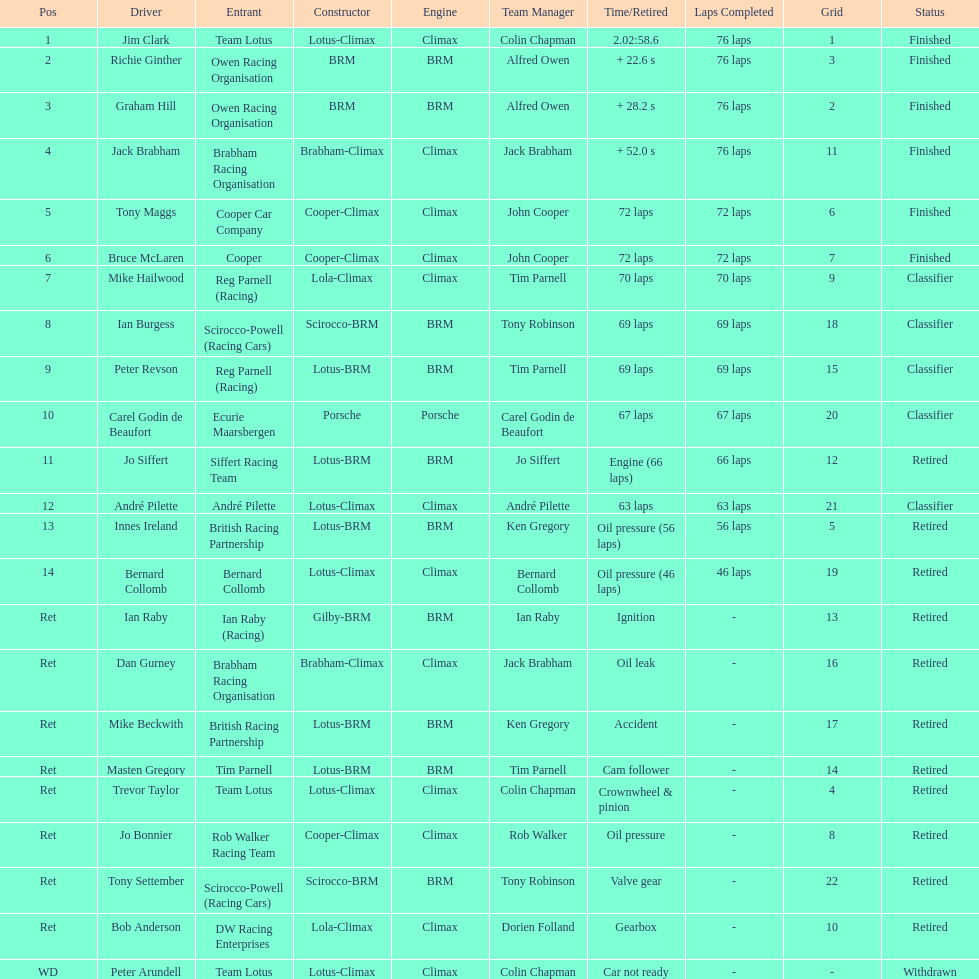How many racers had cooper-climax as their constructor? 3. 